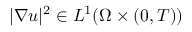Convert formula to latex. <formula><loc_0><loc_0><loc_500><loc_500>| \nabla u | ^ { 2 } \in L ^ { 1 } ( \Omega \times ( 0 , T ) )</formula> 